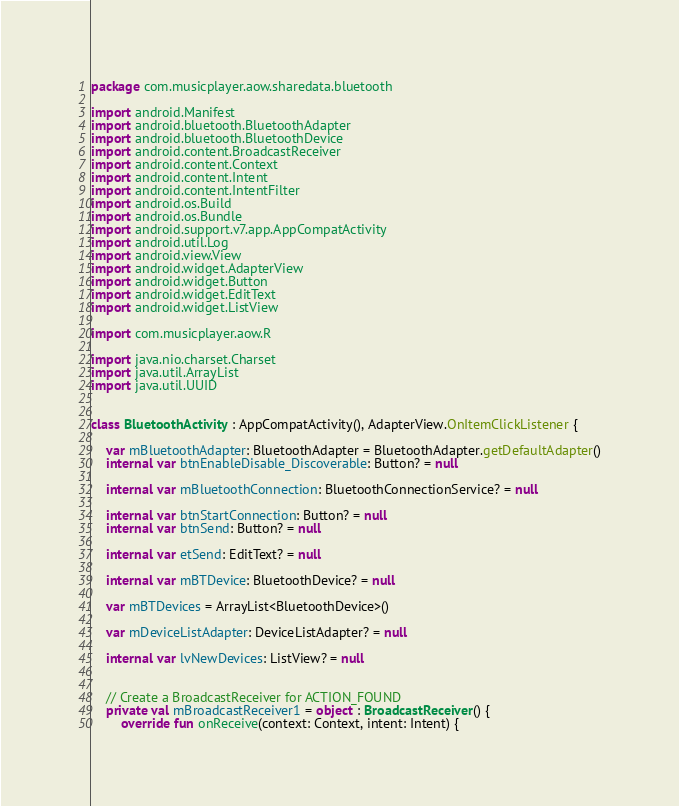<code> <loc_0><loc_0><loc_500><loc_500><_Kotlin_>package com.musicplayer.aow.sharedata.bluetooth

import android.Manifest
import android.bluetooth.BluetoothAdapter
import android.bluetooth.BluetoothDevice
import android.content.BroadcastReceiver
import android.content.Context
import android.content.Intent
import android.content.IntentFilter
import android.os.Build
import android.os.Bundle
import android.support.v7.app.AppCompatActivity
import android.util.Log
import android.view.View
import android.widget.AdapterView
import android.widget.Button
import android.widget.EditText
import android.widget.ListView

import com.musicplayer.aow.R

import java.nio.charset.Charset
import java.util.ArrayList
import java.util.UUID


class BluetoothActivity : AppCompatActivity(), AdapterView.OnItemClickListener {

    var mBluetoothAdapter: BluetoothAdapter = BluetoothAdapter.getDefaultAdapter()
    internal var btnEnableDisable_Discoverable: Button? = null

    internal var mBluetoothConnection: BluetoothConnectionService? = null

    internal var btnStartConnection: Button? = null
    internal var btnSend: Button? = null

    internal var etSend: EditText? = null

    internal var mBTDevice: BluetoothDevice? = null

    var mBTDevices = ArrayList<BluetoothDevice>()

    var mDeviceListAdapter: DeviceListAdapter? = null

    internal var lvNewDevices: ListView? = null


    // Create a BroadcastReceiver for ACTION_FOUND
    private val mBroadcastReceiver1 = object : BroadcastReceiver() {
        override fun onReceive(context: Context, intent: Intent) {</code> 